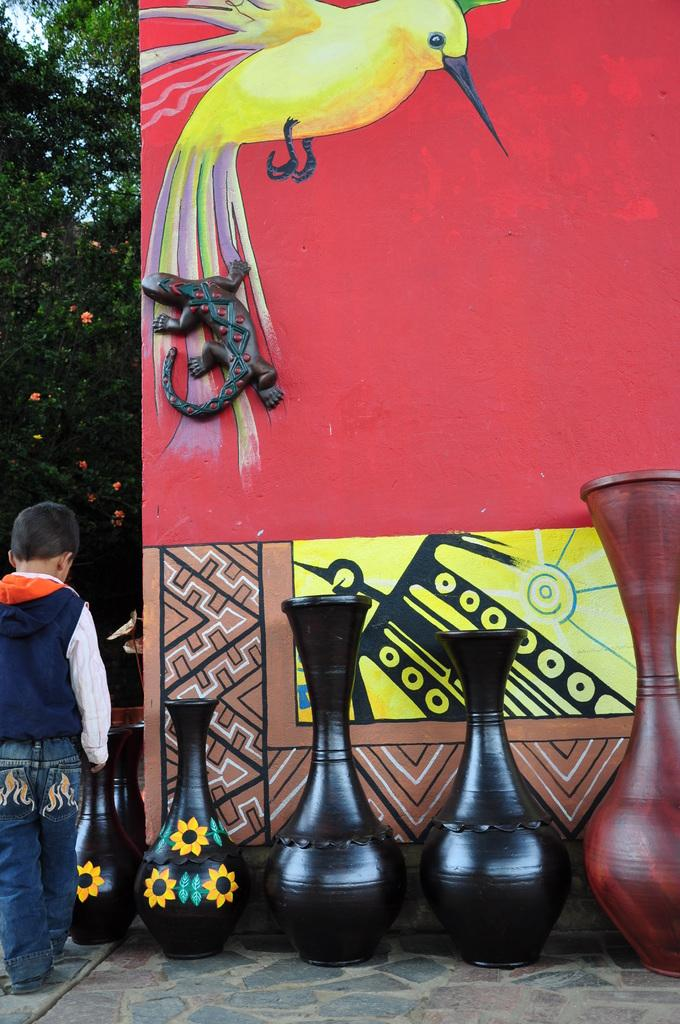What objects are in the foreground of the image? There are flower pots in the foreground of the image. What is the boy in the image doing? The boy is standing on the floor in the image. What type of signage is present in the image? There is a hoarding in the image. What type of vegetation can be seen in the image? There are trees in the image. What part of the natural environment is visible in the image? The sky is visible in the image. Based on the presence of the sky and the absence of any artificial lighting, when do you think this image was taken? The image was likely taken during the day. What type of pollution is visible in the image? There is no visible pollution in the image. What is the boy's interest in the flower pots? The image does not provide any information about the boy's interests, so we cannot determine his interest in the flower pots. 